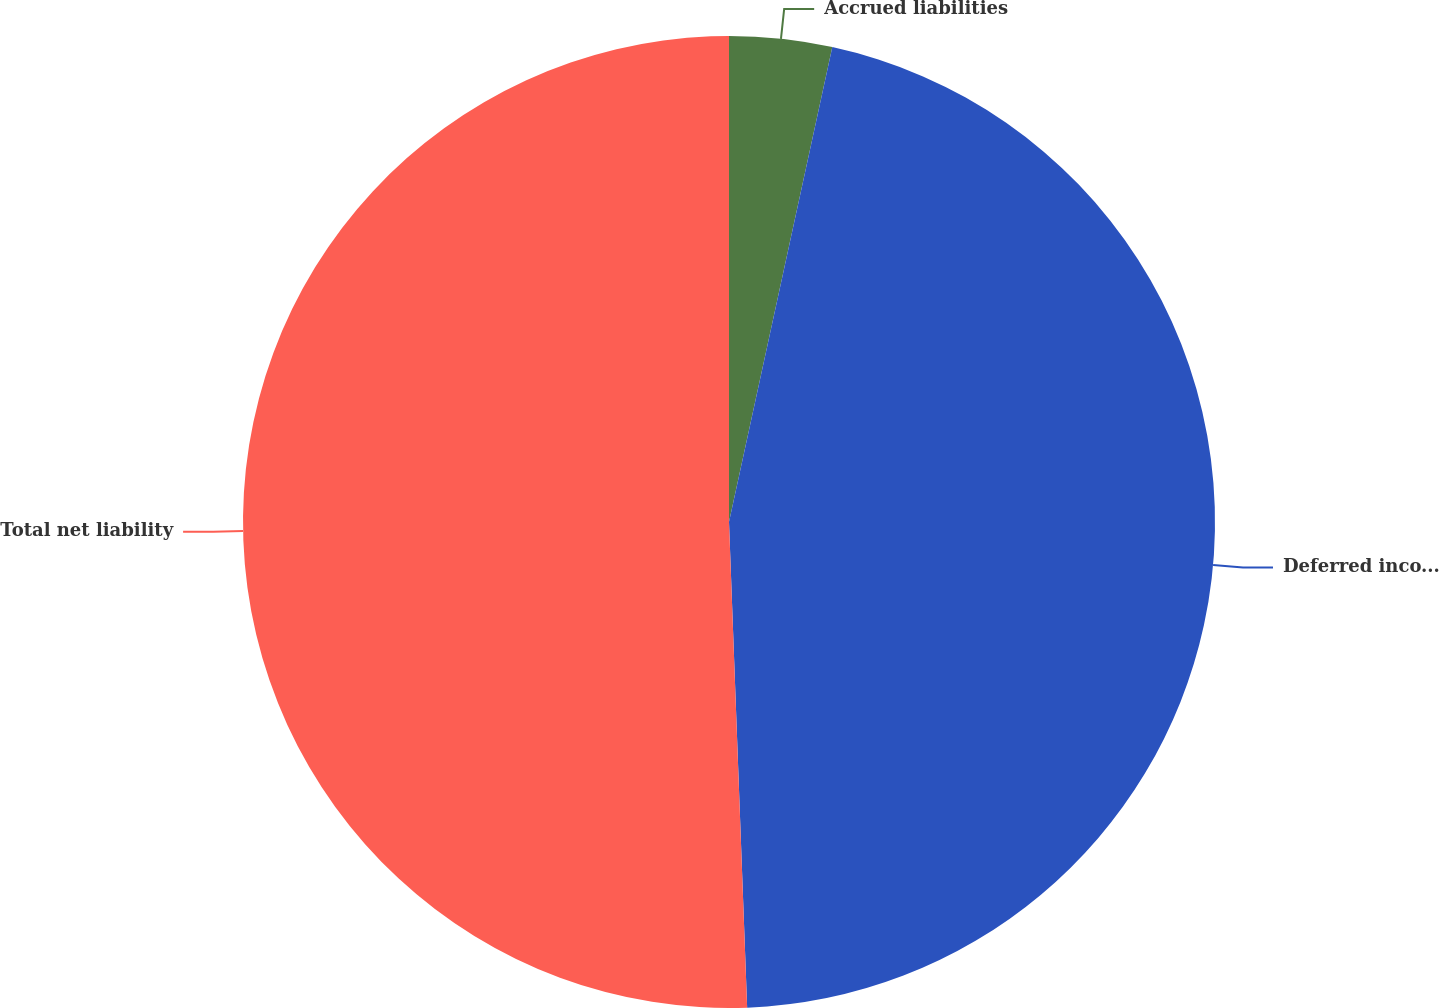Convert chart to OTSL. <chart><loc_0><loc_0><loc_500><loc_500><pie_chart><fcel>Accrued liabilities<fcel>Deferred income taxes and<fcel>Total net liability<nl><fcel>3.41%<fcel>46.0%<fcel>50.6%<nl></chart> 